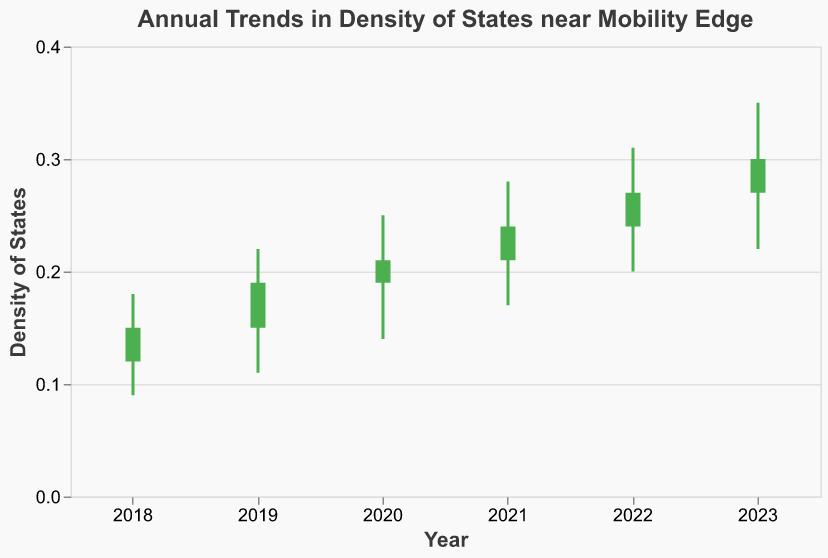What is the title of the figure? The title of the figure is generally located at the top of the chart. In this case, the title is specified directly in the figure's configuration.
Answer: Annual Trends in Density of States near Mobility Edge How many years of data are represented in the figure? To determine the number of years represented, look at the x-axis of the chart, which is labeled with the years.
Answer: 6 Which year had the highest 'Close' value? To find the year with the highest 'Close' value, compare the 'Close' values for each year.
Answer: 2023 What is the range of the 'High' values from 2018 to 2023? The 'High' values for the years 2018 to 2023 are listed in the dataset: 0.18, 0.22, 0.25, 0.28, 0.31, and 0.35. The range is the difference between the maximum and minimum values.
Answer: 0.26 In which year is the density of states depicted in green? The density of states is depicted in green when the 'Open' value is less than the 'Close' value. Look at the colors of the bars to identify the year.
Answer: 2019 How did the 'Open' value change from 2019 to 2020? To determine the change in the 'Open' value, subtract the 'Open' value in 2019 from that in 2020: 0.19 - 0.15.
Answer: 0.04 What is the average 'Low' value over the years presented? Add the 'Low' values for each year and divide by the number of years: (0.09 + 0.11 + 0.14 + 0.17 + 0.20 + 0.22) / 6.
Answer: 0.155 Which year shows the highest range between 'High' and 'Low' values? The range between 'High' and 'Low' values for each year is calculated as ('High' - 'Low'). Calculate these for each year to find the highest range.
Answer: 2023 How does the 'High' value in 2023 compare to that in 2020? Compare the 'High' values for 2023 and 2020, which are 0.35 and 0.25, respectively, by subtracting the latter from the former: 0.35 - 0.25.
Answer: 0.10 